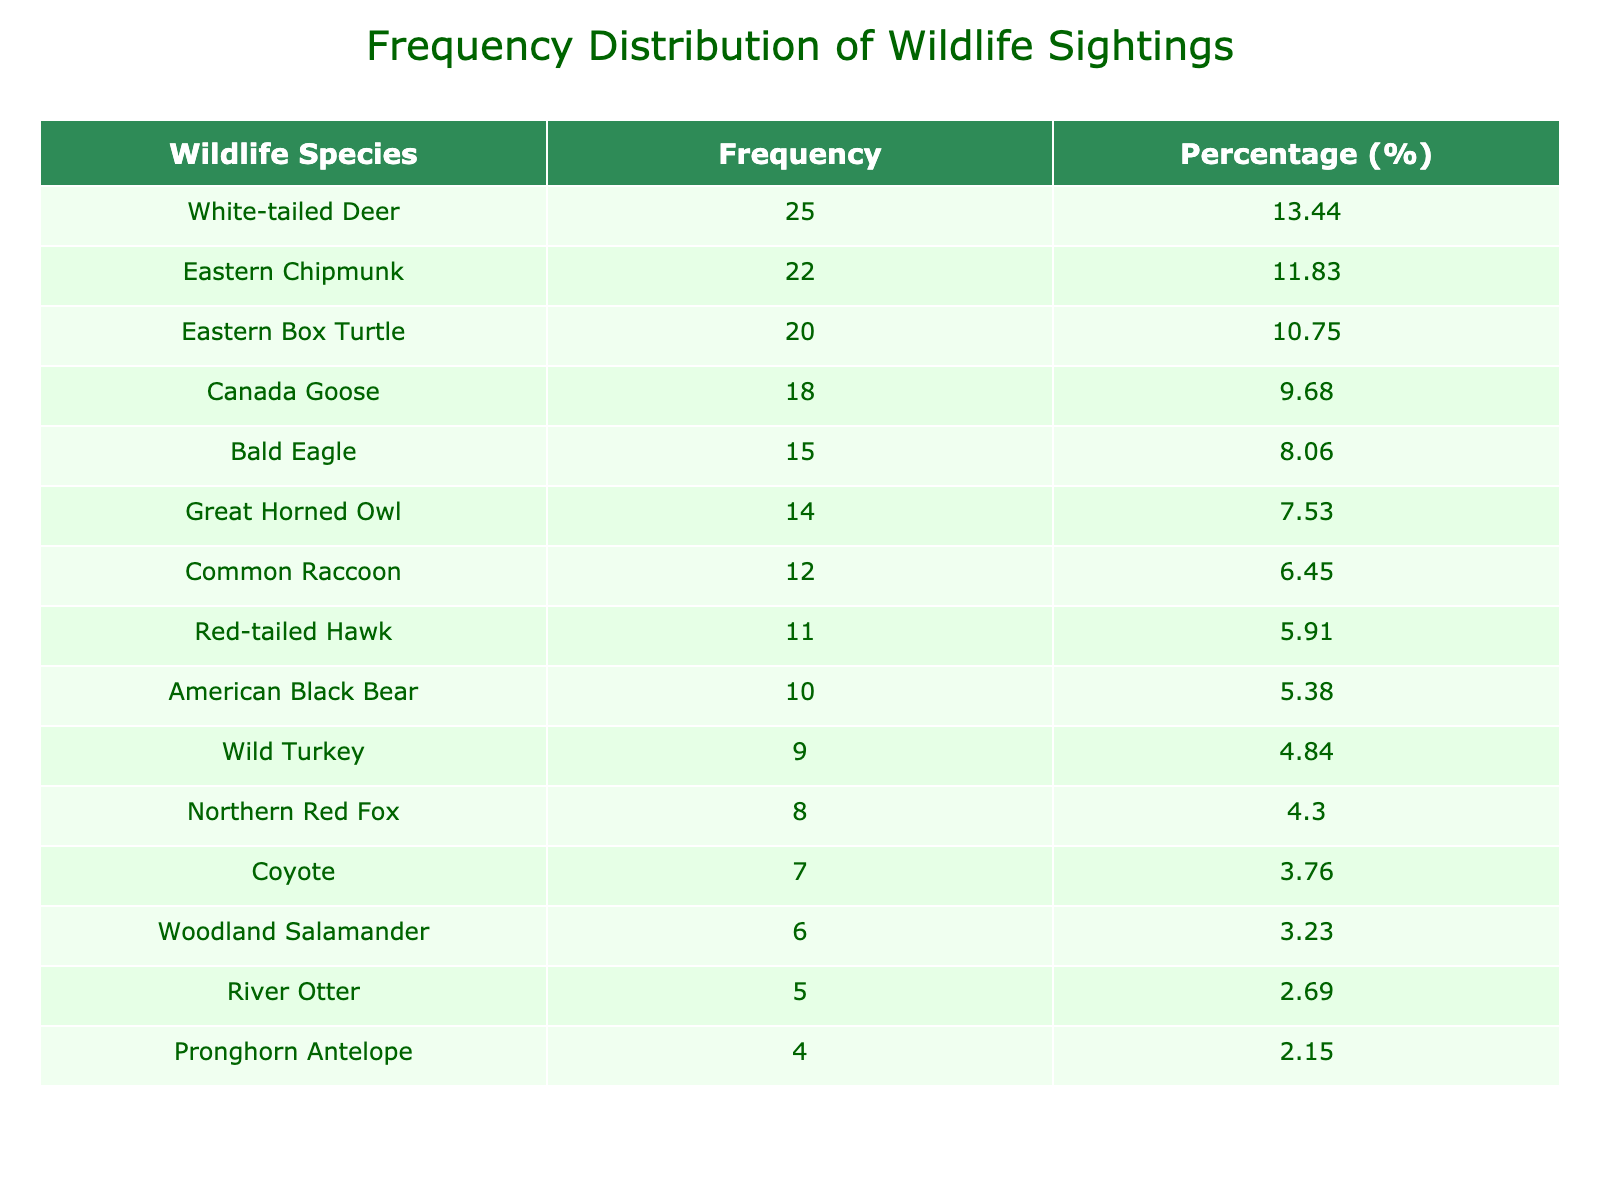What is the most frequently sighted wildlife species during the ranger-led tours? By looking at the "Frequency" column, we can see that the species with the highest count is "White-tailed Deer" with a frequency of 25 sightings.
Answer: White-tailed Deer How many total sightings were recorded for all wildlife species combined? To find the total sightings, we sum the "Count" values for all species: 25 + 10 + 15 + 8 + 12 + 20 + 14 + 18 + 11 + 9 + 22 + 5 + 7 + 6 + 4 =  271.
Answer: 271 What percentage of total wildlife sightings does the "Bald Eagle" represent? The "Bald Eagle" has a count of 15 sightings. To find the percentage, we calculate (15 / 271) * 100, which equals approximately 5.54%.
Answer: 5.54% Is the number of "River Otter" sightings greater than the number of "Coyote" sightings? The count for "River Otter" is 5, and for "Coyote" it is 7. Since 5 is less than 7, the statement is false.
Answer: No What is the average number of sightings for the wildlife species listed? To calculate the average, we take the total number of sightings (271) and divide it by the number of species (15). Thus, the average is 271 / 15 = approximately 18.07.
Answer: 18.07 Which wildlife species had the second-highest frequency of sightings? By checking the "Frequency" column in descending order, the second-highest frequency belongs to "Eastern Chipmunk" with a count of 22 sightings.
Answer: Eastern Chipmunk Did more than 20 sightings occur for any species other than "White-tailed Deer"? The only species with more than 20 sightings is "Eastern Chipmunk" with 22 sightings, so the answer is yes; one other species had more than 20 sightings.
Answer: Yes What is the total frequency of sightings for species starting with the letter 'E'? The species starting with 'E' are "Eastern Box Turtle", "Eastern Chipmunk", and "Great Horned Owl", which have counts of 20, 22, and 14 respectively. Summing those gives 20 + 22 + 14 = 56.
Answer: 56 How many species have sightings of 10 or more? The species with 10 or more sightings are: White-tailed Deer, American Black Bear, Bald Eagle, Common Raccoon, Eastern Box Turtle, Great Horned Owl, Canada Goose, Red-tailed Hawk, Eastern Chipmunk, so a total of 9 species fall into this category.
Answer: 9 